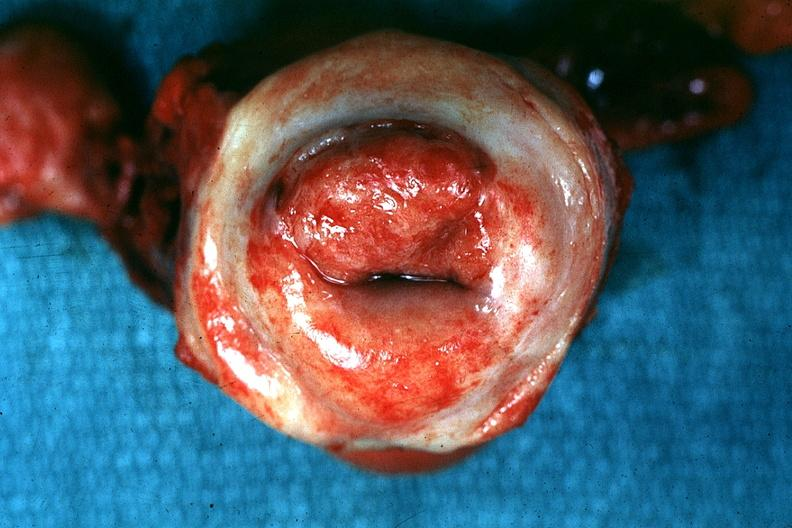what is present?
Answer the question using a single word or phrase. Cervical carcinoma 